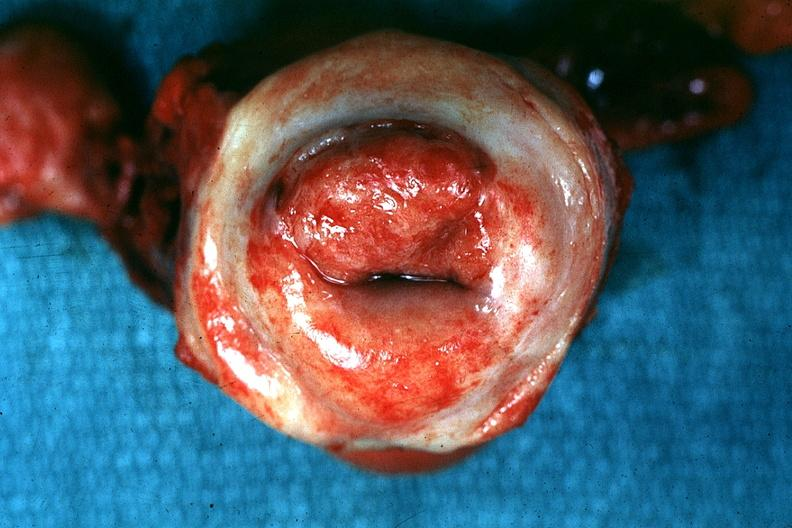what is present?
Answer the question using a single word or phrase. Cervical carcinoma 